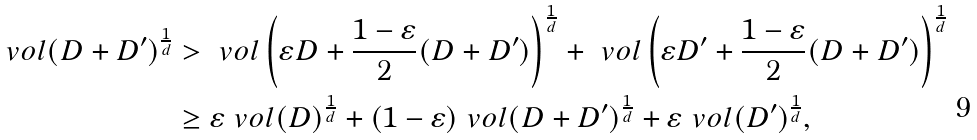Convert formula to latex. <formula><loc_0><loc_0><loc_500><loc_500>\ v o l ( D + D ^ { \prime } ) ^ { \frac { 1 } { d } } & > \ v o l \left ( \varepsilon D + \frac { 1 - \varepsilon } { 2 } ( D + D ^ { \prime } ) \right ) ^ { \frac { 1 } { d } } + \ v o l \left ( \varepsilon D ^ { \prime } + \frac { 1 - \varepsilon } { 2 } ( D + D ^ { \prime } ) \right ) ^ { \frac { 1 } { d } } \\ & \geq \varepsilon \ v o l ( D ) ^ { \frac { 1 } { d } } + ( 1 - \varepsilon ) \ v o l ( D + D ^ { \prime } ) ^ { \frac { 1 } { d } } + \varepsilon \ v o l ( D ^ { \prime } ) ^ { \frac { 1 } { d } } ,</formula> 